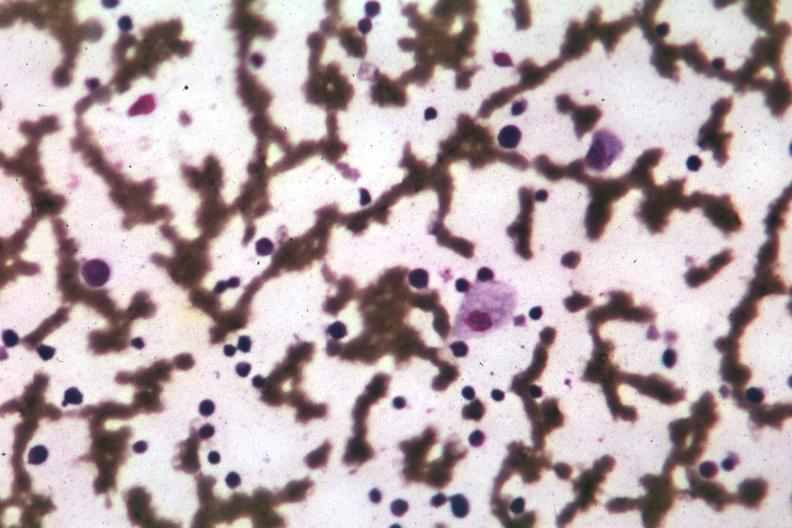s gaucher cell present?
Answer the question using a single word or phrase. Yes 